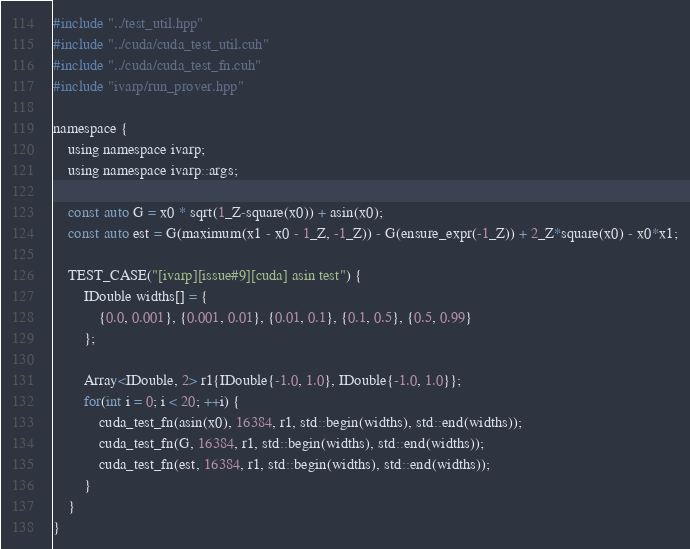<code> <loc_0><loc_0><loc_500><loc_500><_Cuda_>#include "../test_util.hpp"
#include "../cuda/cuda_test_util.cuh"
#include "../cuda/cuda_test_fn.cuh"
#include "ivarp/run_prover.hpp"

namespace {
	using namespace ivarp;
	using namespace ivarp::args;

	const auto G = x0 * sqrt(1_Z-square(x0)) + asin(x0);
    const auto est = G(maximum(x1 - x0 - 1_Z, -1_Z)) - G(ensure_expr(-1_Z)) + 2_Z*square(x0) - x0*x1;

	TEST_CASE("[ivarp][issue#9][cuda] asin test") {
		IDouble widths[] = {
			{0.0, 0.001}, {0.001, 0.01}, {0.01, 0.1}, {0.1, 0.5}, {0.5, 0.99}
		};

		Array<IDouble, 2> r1{IDouble{-1.0, 1.0}, IDouble{-1.0, 1.0}};
		for(int i = 0; i < 20; ++i) {
			cuda_test_fn(asin(x0), 16384, r1, std::begin(widths), std::end(widths));
			cuda_test_fn(G, 16384, r1, std::begin(widths), std::end(widths));
			cuda_test_fn(est, 16384, r1, std::begin(widths), std::end(widths));
		}
	}
}

</code> 